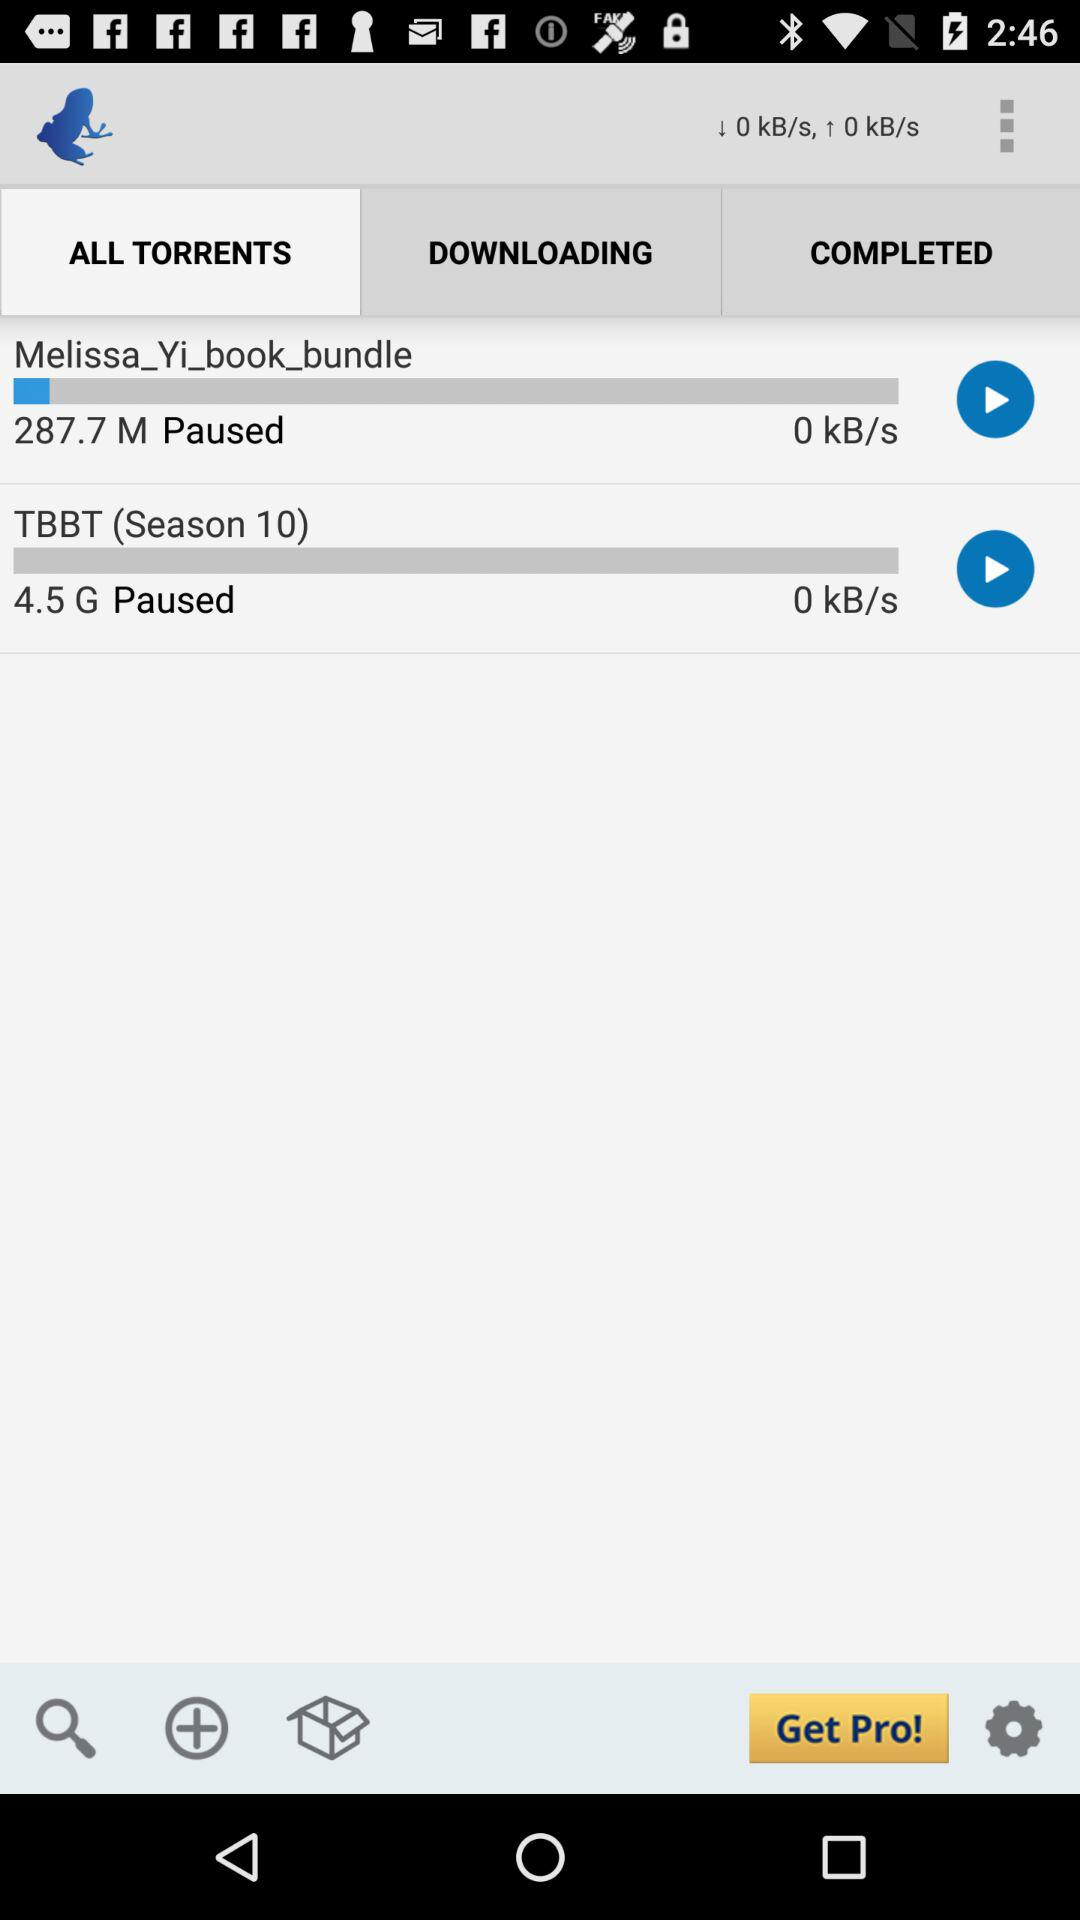Which tab is selected? The selected tab is "ALL TORRENTS". 